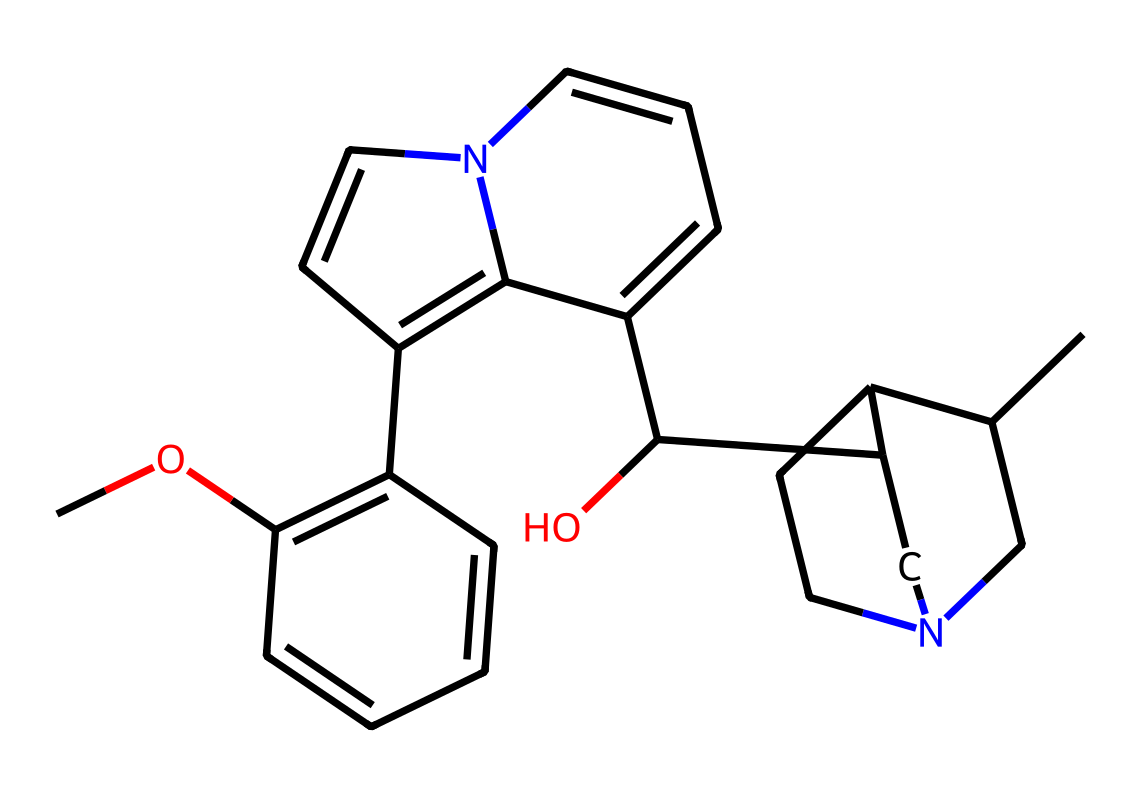How many rings are present in this structure? By examining the rendered structure, I can identify that there are several distinct cyclic components in the molecule. Each ring can be counted individually. The structural formula reveals that there are four interconnected ring structures in quinine.
Answer: four What functional groups are visible in this chemical structure? Analyzing the structure, I note the presence of a hydroxyl (-OH) group and a methoxy (-OCH3) group, which are common in natural products, especially alkaloids. The hydroxyl group is visible as -OH, contributing to the compound's properties.
Answer: hydroxyl and methoxy How many carbon atoms are in quinine? Counting the carbon atoms in the SMILES representation and confirming through the structure, I find that there are 24 carbon atoms present. Each carbon atom corresponds to a vertex in the structure.
Answer: twenty-four What type of compound is quinine classified as? Given that quinine contains a basic nitrogen atom incorporated within a cyclic structure and is derived from plant sources, it is classified as an alkaloid. Alkaloids typically contain basic nitrogen atoms and exhibit pharmacological effects.
Answer: alkaloid Does quinine contain any nitrogen atoms? Review of the structure indicates that there are nitrogen atoms present in the ring systems of the compound, which are characteristic of alkaloids. The presence of nitrogen is evident as the atoms are part of the ring structure.
Answer: yes What is the significance of the Bitter taste in quinine? Quinine's structure includes a nitrogen atom, which is a common feature in many bitter compounds, especially alkaloids. This nitrogen contributes to the overall taste and is responsible for the bitter flavor of quinine.
Answer: bitter 